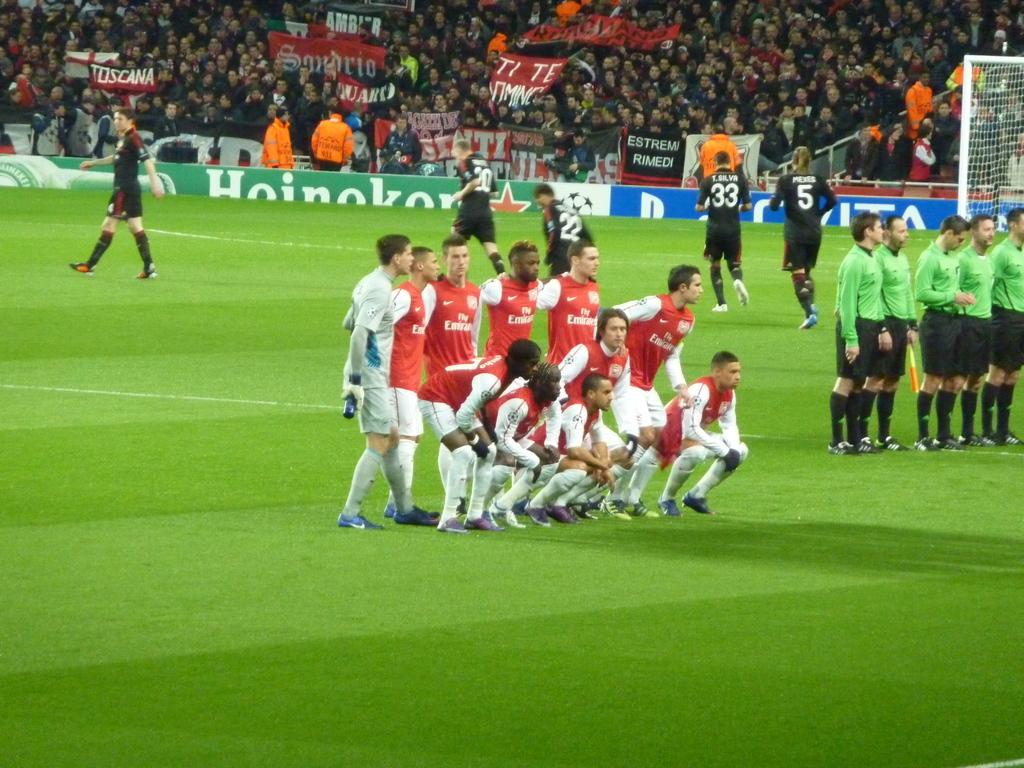<image>
Relay a brief, clear account of the picture shown. Soccer players on a field sponsored by Heinekin. 